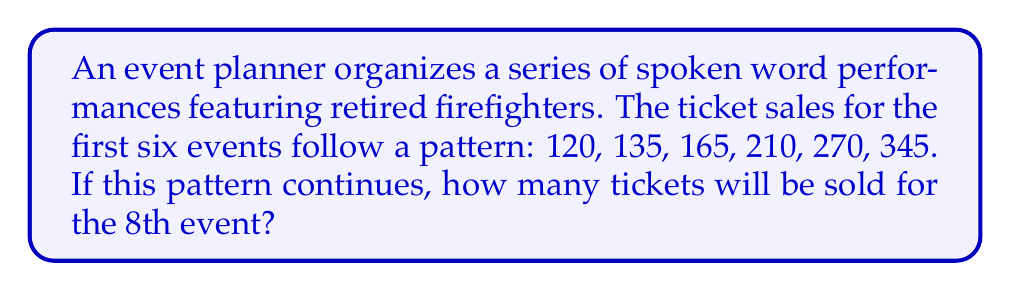Can you solve this math problem? Let's analyze the pattern step-by-step:

1) First, calculate the difference between each consecutive pair of numbers:
   135 - 120 = 15
   165 - 135 = 30
   210 - 165 = 45
   270 - 210 = 60
   345 - 270 = 75

2) We can see that the difference is increasing by 15 each time:
   15, 30, 45, 60, 75

3) This suggests that the sequence follows the pattern of a quadratic function.

4) The general form of a quadratic sequence is:
   $$a_n = an^2 + bn + c$$
   where $n$ is the term number and $a$, $b$, and $c$ are constants.

5) Given the first term (120) and the pattern of differences, we can deduce:
   $$a_n = \frac{15}{2}n^2 - \frac{15}{2}n + 120$$

6) To verify, let's check the 6th term:
   $$a_6 = \frac{15}{2}(6^2) - \frac{15}{2}(6) + 120 = 270 + 75 = 345$$

7) Now, to find the 8th term, we substitute $n = 8$:
   $$a_8 = \frac{15}{2}(8^2) - \frac{15}{2}(8) + 120$$
   $$= 480 - 60 + 120 = 540$$

Therefore, 540 tickets will be sold for the 8th event.
Answer: 540 